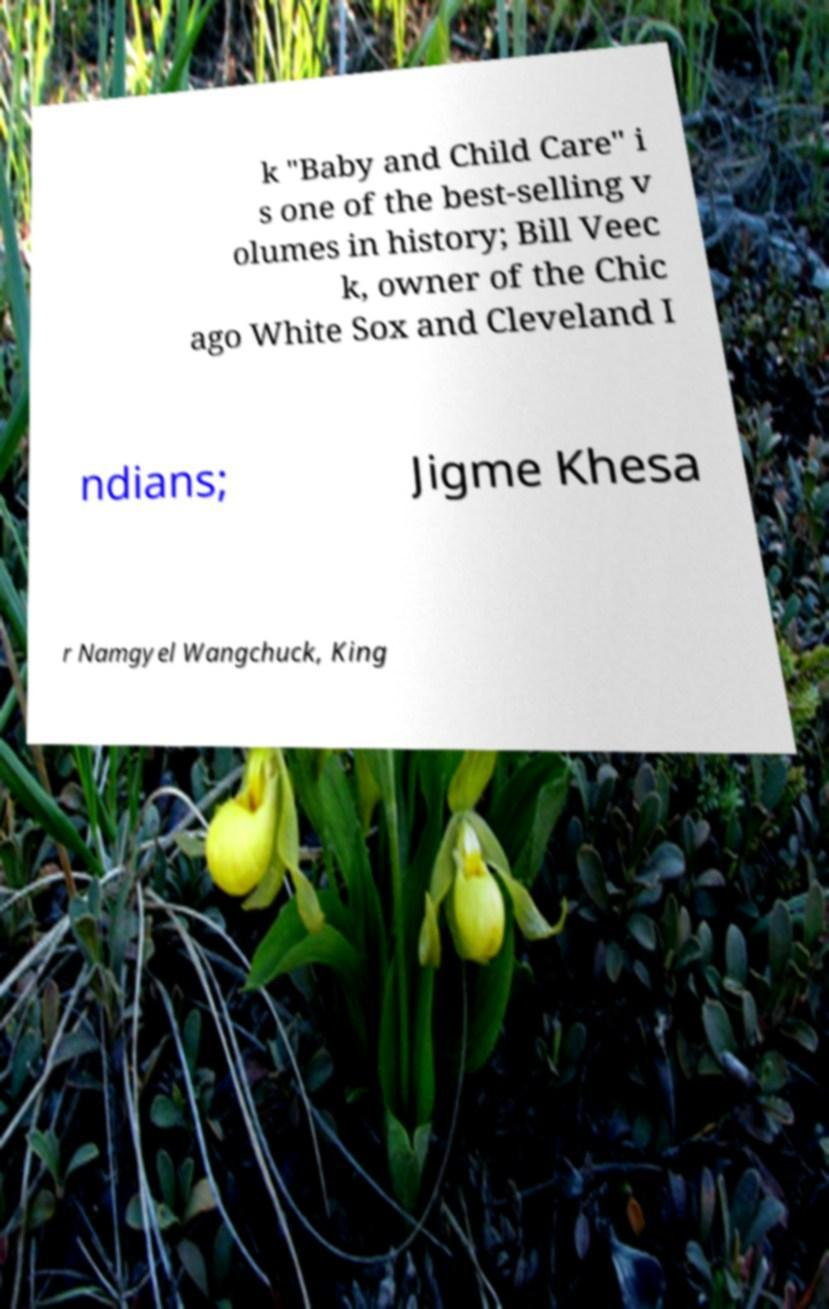Could you assist in decoding the text presented in this image and type it out clearly? k "Baby and Child Care" i s one of the best-selling v olumes in history; Bill Veec k, owner of the Chic ago White Sox and Cleveland I ndians; Jigme Khesa r Namgyel Wangchuck, King 